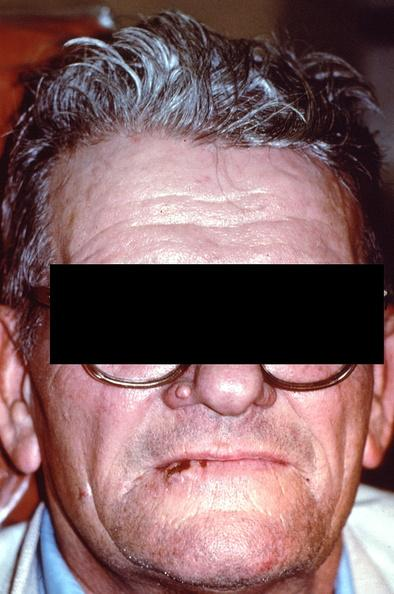where does this belong to?
Answer the question using a single word or phrase. Gastrointestinal system 